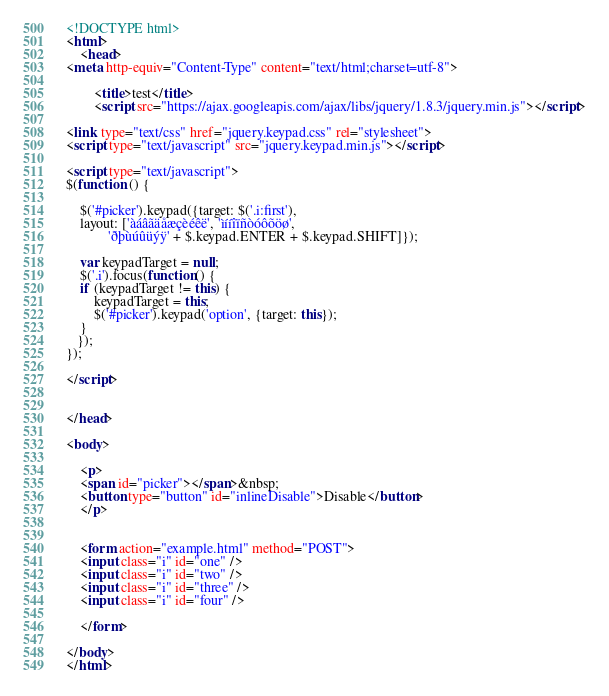Convert code to text. <code><loc_0><loc_0><loc_500><loc_500><_HTML_><!DOCTYPE html>
<html>
    <head>
<meta http-equiv="Content-Type" content="text/html;charset=utf-8">
    
        <title>test</title>
        <script src="https://ajax.googleapis.com/ajax/libs/jquery/1.8.3/jquery.min.js"></script>

<link type="text/css" href="jquery.keypad.css" rel="stylesheet"> 
<script type="text/javascript" src="jquery.keypad.min.js"></script>

<script type="text/javascript">
$(function () {
    
    $('#picker').keypad({target: $('.i:first'), 
    layout: ['àáâãäåæçèéêë', 'ìííîïñòóôõöø', 
            'ðþùúûüýÿ' + $.keypad.ENTER + $.keypad.SHIFT]});

    var keypadTarget = null; 
    $('.i').focus(function() { 
    if (keypadTarget != this) { 
        keypadTarget = this; 
        $('#picker').keypad('option', {target: this}); 
    } 
   }); 
});

</script>
        
        
</head>

<body>

    <p>
    <span id="picker"></span>&nbsp;
	<button type="button" id="inlineDisable">Disable</button>
    </p>


    <form action="example.html" method="POST">
    <input class="i" id="one" />
    <input class="i" id="two" />
    <input class="i" id="three" />
    <input class="i" id="four" />
    
    </form>
    
</body>
</html>




</code> 